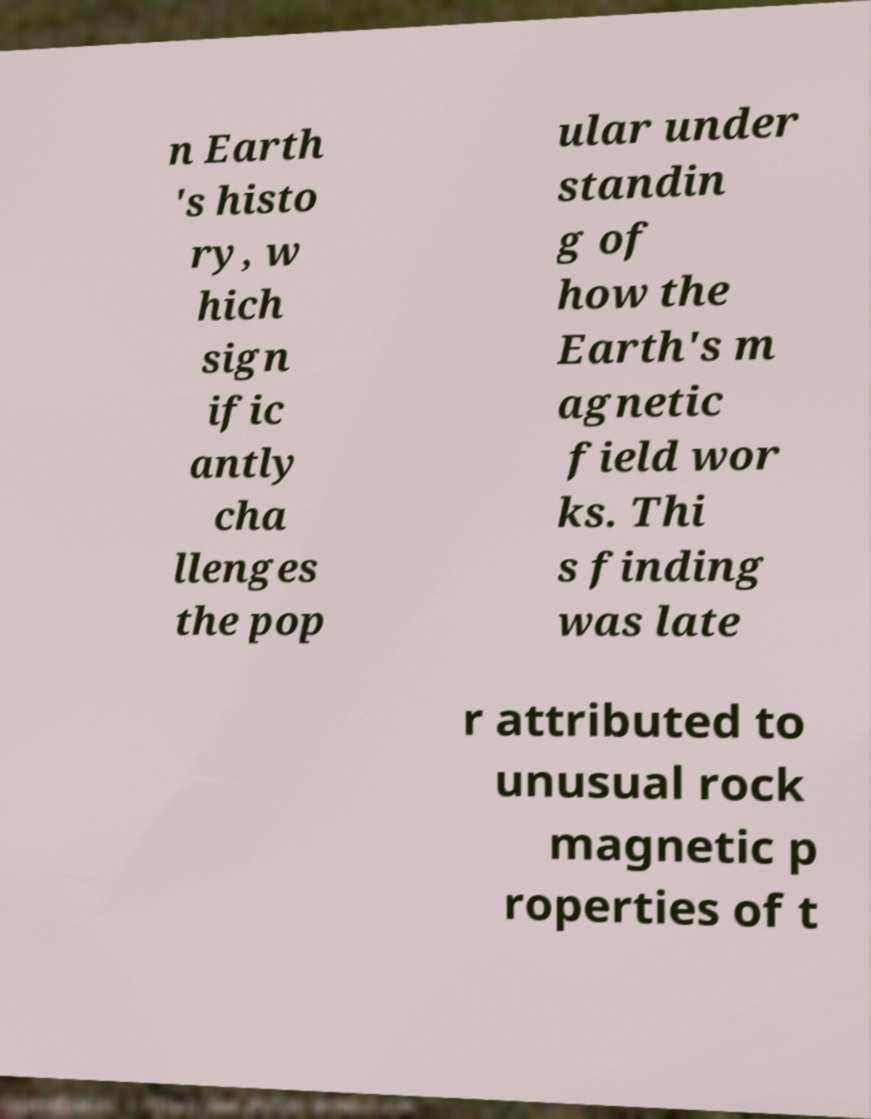Could you assist in decoding the text presented in this image and type it out clearly? n Earth 's histo ry, w hich sign ific antly cha llenges the pop ular under standin g of how the Earth's m agnetic field wor ks. Thi s finding was late r attributed to unusual rock magnetic p roperties of t 